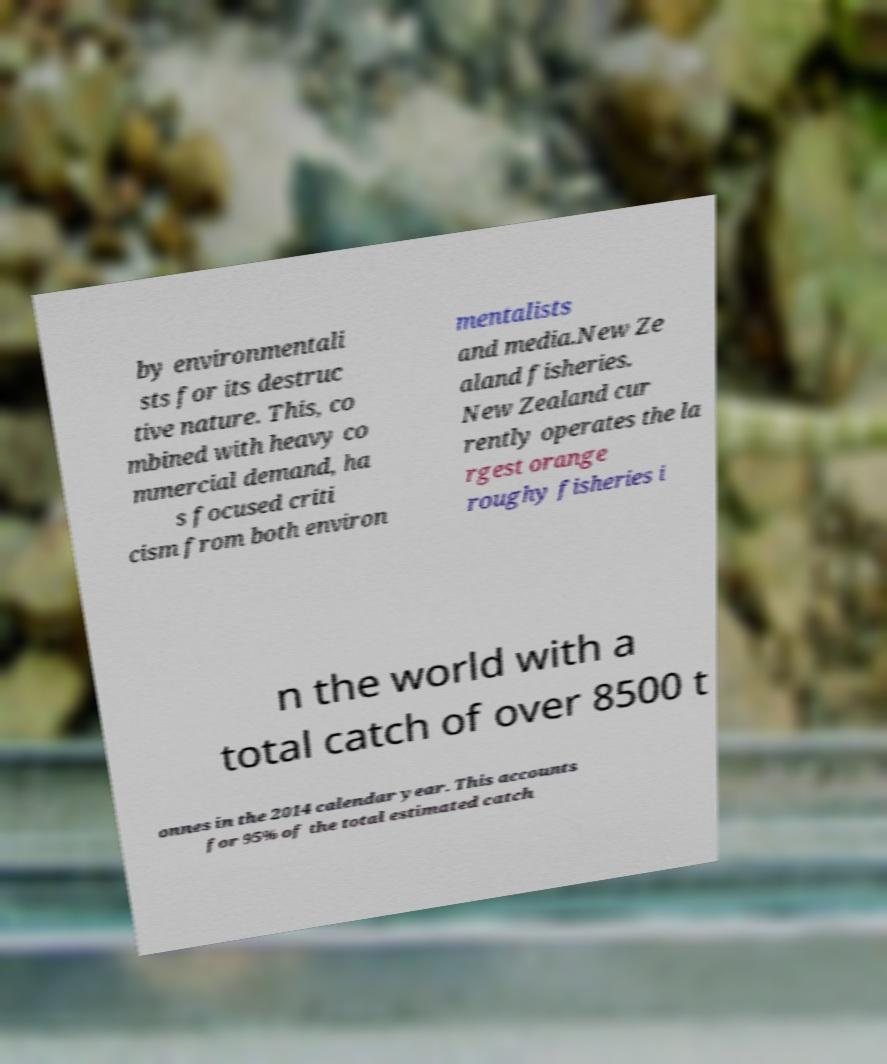Could you assist in decoding the text presented in this image and type it out clearly? by environmentali sts for its destruc tive nature. This, co mbined with heavy co mmercial demand, ha s focused criti cism from both environ mentalists and media.New Ze aland fisheries. New Zealand cur rently operates the la rgest orange roughy fisheries i n the world with a total catch of over 8500 t onnes in the 2014 calendar year. This accounts for 95% of the total estimated catch 